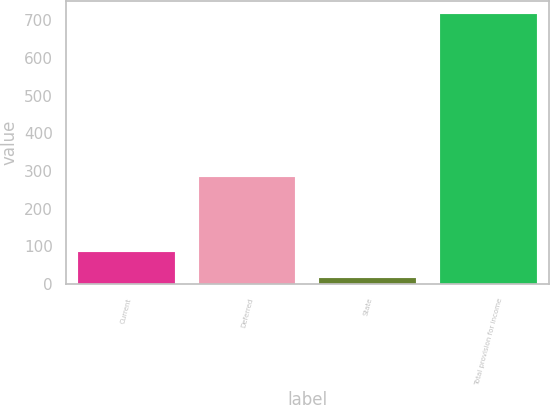<chart> <loc_0><loc_0><loc_500><loc_500><bar_chart><fcel>Current<fcel>Deferred<fcel>State<fcel>Total provision for income<nl><fcel>85<fcel>284<fcel>15<fcel>715<nl></chart> 